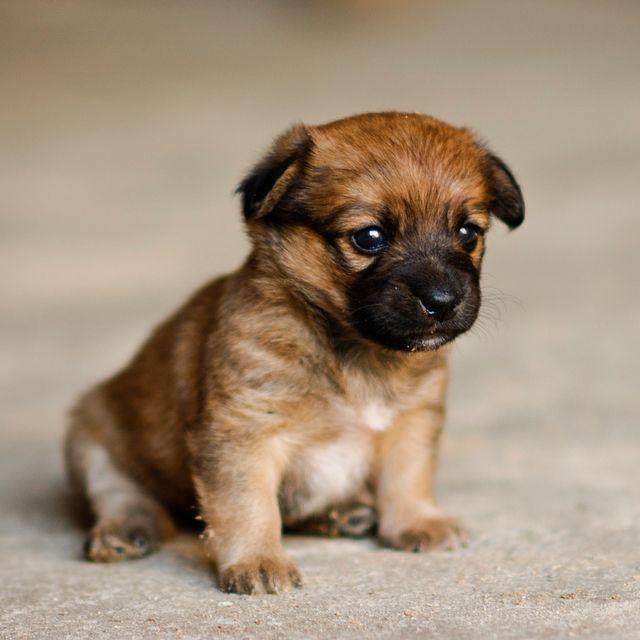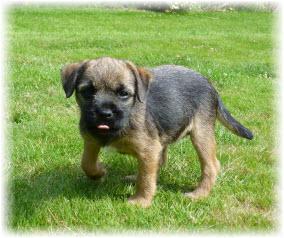The first image is the image on the left, the second image is the image on the right. Assess this claim about the two images: "A collar is visible on the dog in one of the images.". Correct or not? Answer yes or no. No. 